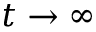Convert formula to latex. <formula><loc_0><loc_0><loc_500><loc_500>t \to \infty</formula> 